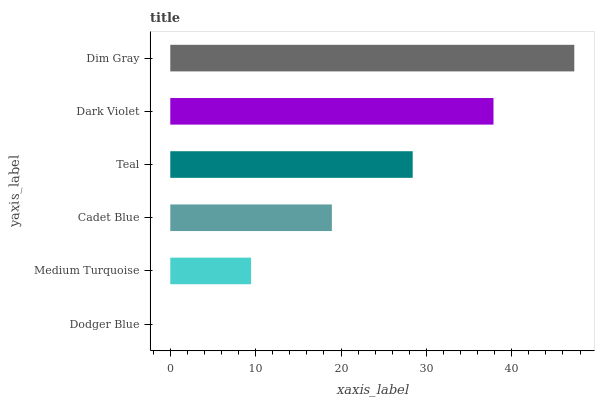Is Dodger Blue the minimum?
Answer yes or no. Yes. Is Dim Gray the maximum?
Answer yes or no. Yes. Is Medium Turquoise the minimum?
Answer yes or no. No. Is Medium Turquoise the maximum?
Answer yes or no. No. Is Medium Turquoise greater than Dodger Blue?
Answer yes or no. Yes. Is Dodger Blue less than Medium Turquoise?
Answer yes or no. Yes. Is Dodger Blue greater than Medium Turquoise?
Answer yes or no. No. Is Medium Turquoise less than Dodger Blue?
Answer yes or no. No. Is Teal the high median?
Answer yes or no. Yes. Is Cadet Blue the low median?
Answer yes or no. Yes. Is Dodger Blue the high median?
Answer yes or no. No. Is Dim Gray the low median?
Answer yes or no. No. 